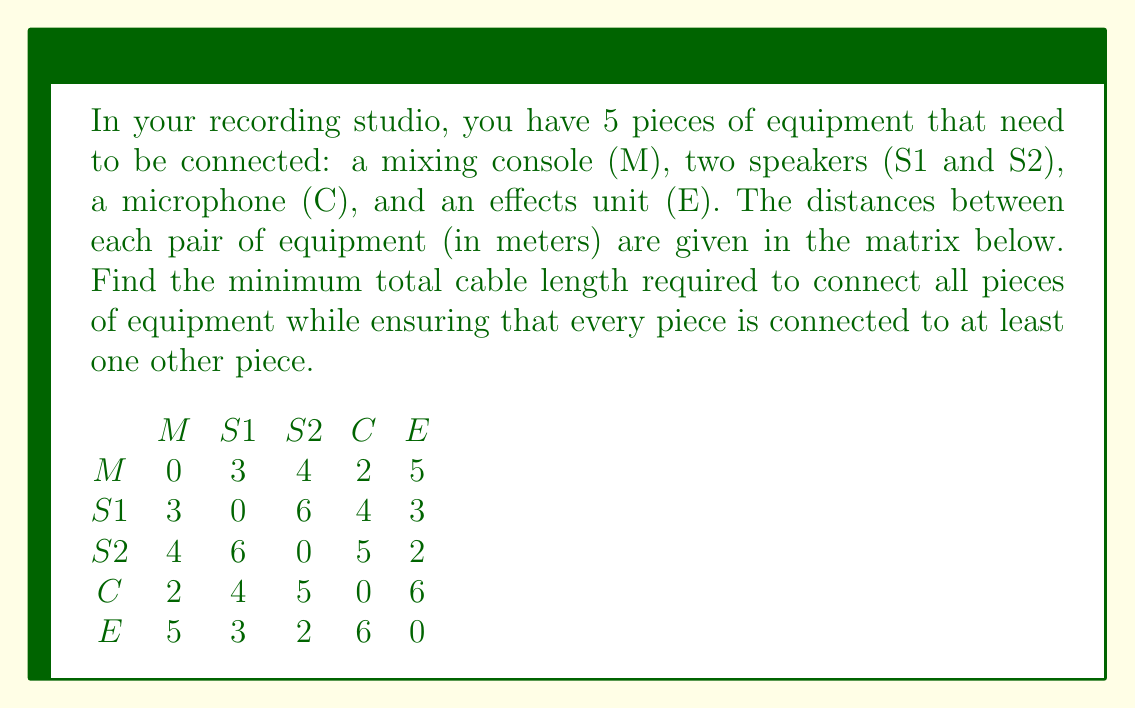Could you help me with this problem? This problem can be solved using Kruskal's algorithm to find the Minimum Spanning Tree (MST) of the graph representing the studio equipment.

Step 1: Sort all edges in ascending order of weight (distance):
1. (M, C) : 2
2. (S2, E) : 2
3. (M, S1) : 3
4. (S1, E) : 3
5. (M, S2) : 4
6. (S1, C) : 4
7. (M, E) : 5
8. (S2, C) : 5
9. (S1, S2) : 6
10. (C, E) : 6

Step 2: Apply Kruskal's algorithm:
1. Add (M, C) : 2
2. Add (S2, E) : 2
3. Add (M, S1) : 3
4. Add (S1, E) : 3

At this point, all vertices are connected, and we have a minimum spanning tree.

The total cable length is the sum of the selected edges:
$$ 2 + 2 + 3 + 3 = 10 $$

[asy]
unitsize(30);
pair M = (0,0), S1 = (1,1), S2 = (2,0), C = (0,1), E = (2,1);
draw(M--C, blue);
draw(S2--E, blue);
draw(M--S1, blue);
draw(S1--E, blue);
dot(M); dot(S1); dot(S2); dot(C); dot(E);
label("M", M, SW);
label("S1", S1, N);
label("S2", S2, SE);
label("C", C, NW);
label("E", E, NE);
[/asy]
Answer: The minimum total cable length required is 10 meters. 